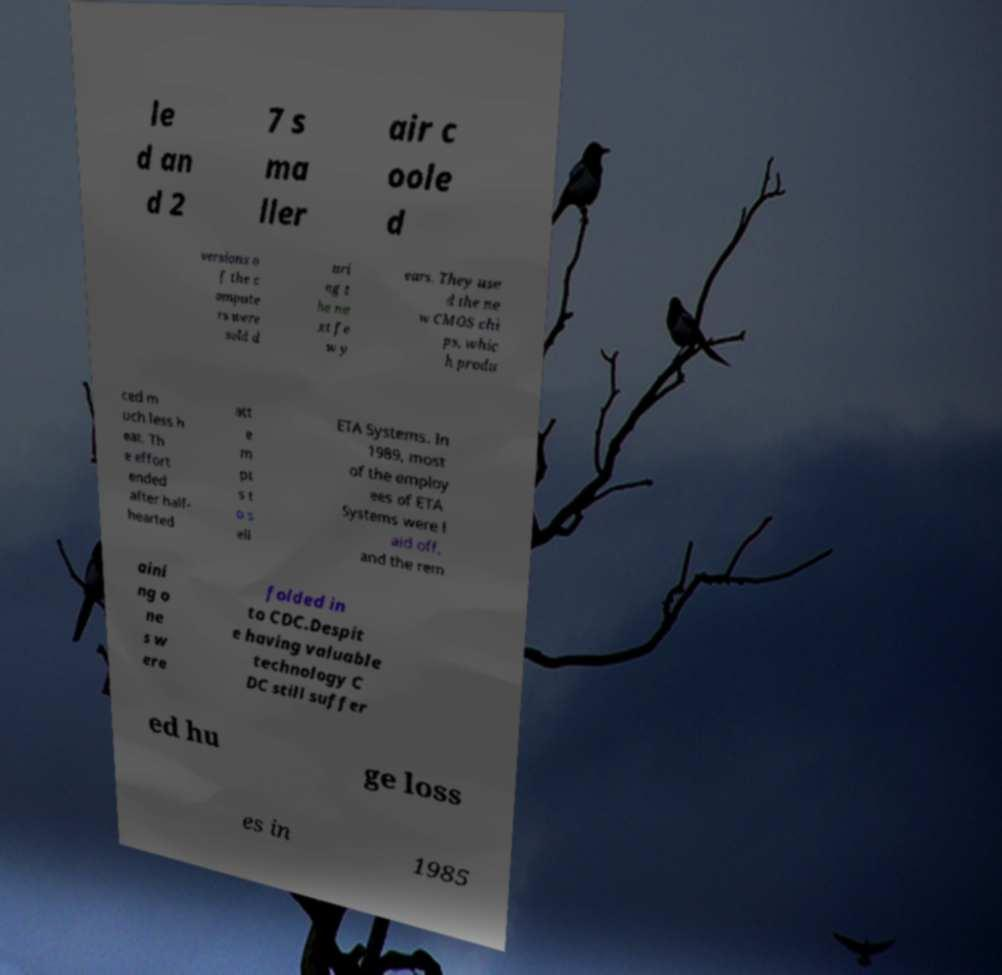For documentation purposes, I need the text within this image transcribed. Could you provide that? le d an d 2 7 s ma ller air c oole d versions o f the c ompute rs were sold d uri ng t he ne xt fe w y ears. They use d the ne w CMOS chi ps, whic h produ ced m uch less h eat. Th e effort ended after half- hearted att e m pt s t o s ell ETA Systems. In 1989, most of the employ ees of ETA Systems were l aid off, and the rem aini ng o ne s w ere folded in to CDC.Despit e having valuable technology C DC still suffer ed hu ge loss es in 1985 